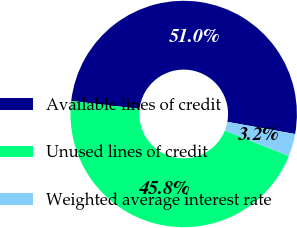Convert chart. <chart><loc_0><loc_0><loc_500><loc_500><pie_chart><fcel>Available lines of credit<fcel>Unused lines of credit<fcel>Weighted average interest rate<nl><fcel>50.99%<fcel>45.79%<fcel>3.22%<nl></chart> 